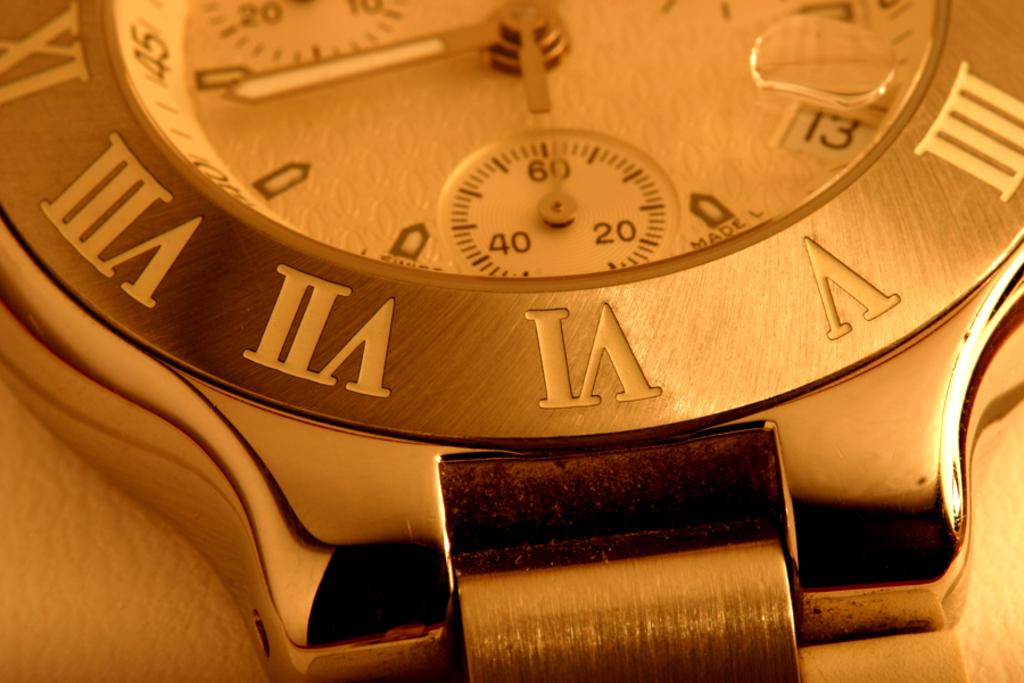What is the short hand on?
Ensure brevity in your answer.  6. What is this product?
Give a very brief answer. Watch. 